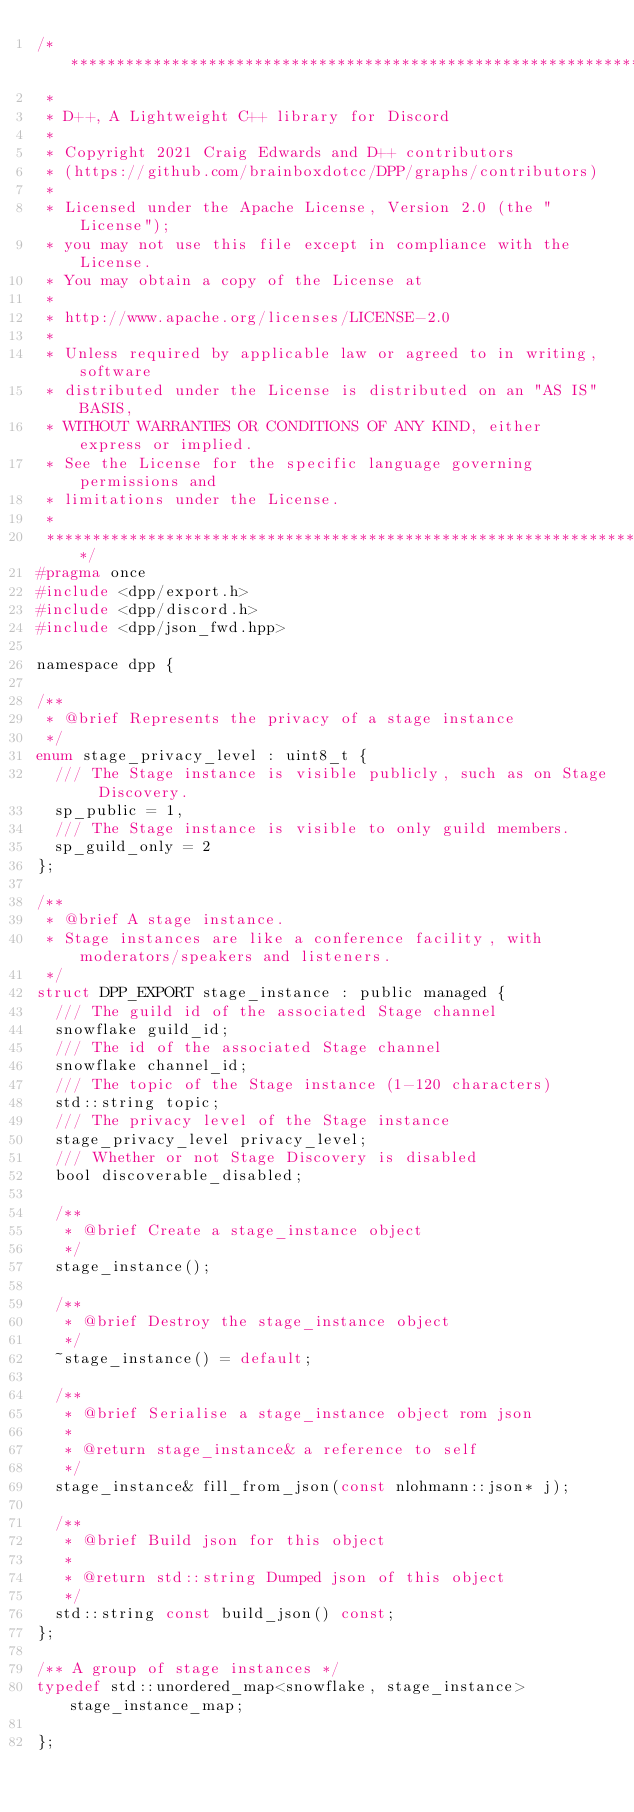<code> <loc_0><loc_0><loc_500><loc_500><_C_>/************************************************************************************
 *
 * D++, A Lightweight C++ library for Discord
 *
 * Copyright 2021 Craig Edwards and D++ contributors 
 * (https://github.com/brainboxdotcc/DPP/graphs/contributors)
 *
 * Licensed under the Apache License, Version 2.0 (the "License");
 * you may not use this file except in compliance with the License.
 * You may obtain a copy of the License at
 *
 * http://www.apache.org/licenses/LICENSE-2.0
 *
 * Unless required by applicable law or agreed to in writing, software
 * distributed under the License is distributed on an "AS IS" BASIS,
 * WITHOUT WARRANTIES OR CONDITIONS OF ANY KIND, either express or implied.
 * See the License for the specific language governing permissions and
 * limitations under the License.
 *
 ************************************************************************************/
#pragma once
#include <dpp/export.h>
#include <dpp/discord.h>
#include <dpp/json_fwd.hpp>

namespace dpp {

/**
 * @brief Represents the privacy of a stage instance
 */
enum stage_privacy_level : uint8_t {
	/// The Stage instance is visible publicly, such as on Stage Discovery.
	sp_public = 1,
	/// The Stage instance is visible to only guild members.
	sp_guild_only = 2
};

/**
 * @brief A stage instance.
 * Stage instances are like a conference facility, with moderators/speakers and listeners.
 */
struct DPP_EXPORT stage_instance : public managed {
	/// The guild id of the associated Stage channel
	snowflake guild_id;
	/// The id of the associated Stage channel
	snowflake channel_id;
	/// The topic of the Stage instance (1-120 characters)
	std::string topic;
	/// The privacy level of the Stage instance
	stage_privacy_level privacy_level;
	/// Whether or not Stage Discovery is disabled
	bool discoverable_disabled;

	/**
	 * @brief Create a stage_instance object
	 */
	stage_instance();

	/**
	 * @brief Destroy the stage_instance object
	 */
	~stage_instance() = default;

	/**
	 * @brief Serialise a stage_instance object rom json
	 *
	 * @return stage_instance& a reference to self
	 */
	stage_instance& fill_from_json(const nlohmann::json* j);

	/**
	 * @brief Build json for this object
	 *
	 * @return std::string Dumped json of this object
	 */
	std::string const build_json() const;
};

/** A group of stage instances */
typedef std::unordered_map<snowflake, stage_instance> stage_instance_map;

};
</code> 